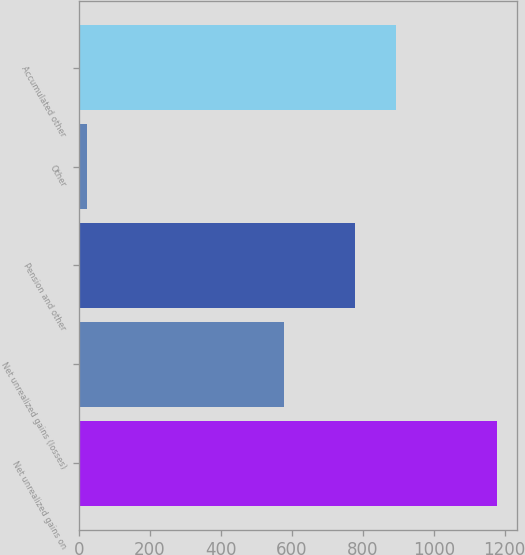<chart> <loc_0><loc_0><loc_500><loc_500><bar_chart><fcel>Net unrealized gains on<fcel>Net unrealized gains (losses)<fcel>Pension and other<fcel>Other<fcel>Accumulated other<nl><fcel>1177<fcel>578<fcel>777<fcel>21<fcel>892.6<nl></chart> 